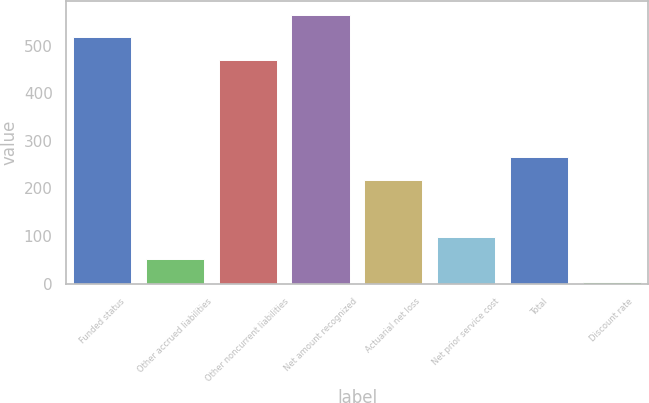Convert chart to OTSL. <chart><loc_0><loc_0><loc_500><loc_500><bar_chart><fcel>Funded status<fcel>Other accrued liabilities<fcel>Other noncurrent liabilities<fcel>Net amount recognized<fcel>Actuarial net loss<fcel>Net prior service cost<fcel>Total<fcel>Discount rate<nl><fcel>518.22<fcel>51.06<fcel>471.2<fcel>565.24<fcel>218.2<fcel>98.08<fcel>265.21<fcel>4.05<nl></chart> 